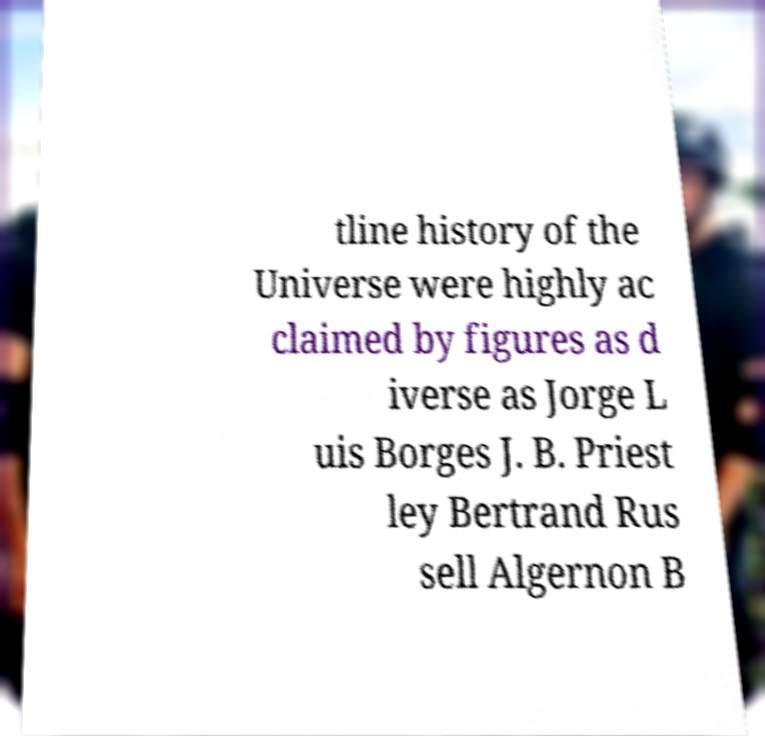What messages or text are displayed in this image? I need them in a readable, typed format. tline history of the Universe were highly ac claimed by figures as d iverse as Jorge L uis Borges J. B. Priest ley Bertrand Rus sell Algernon B 